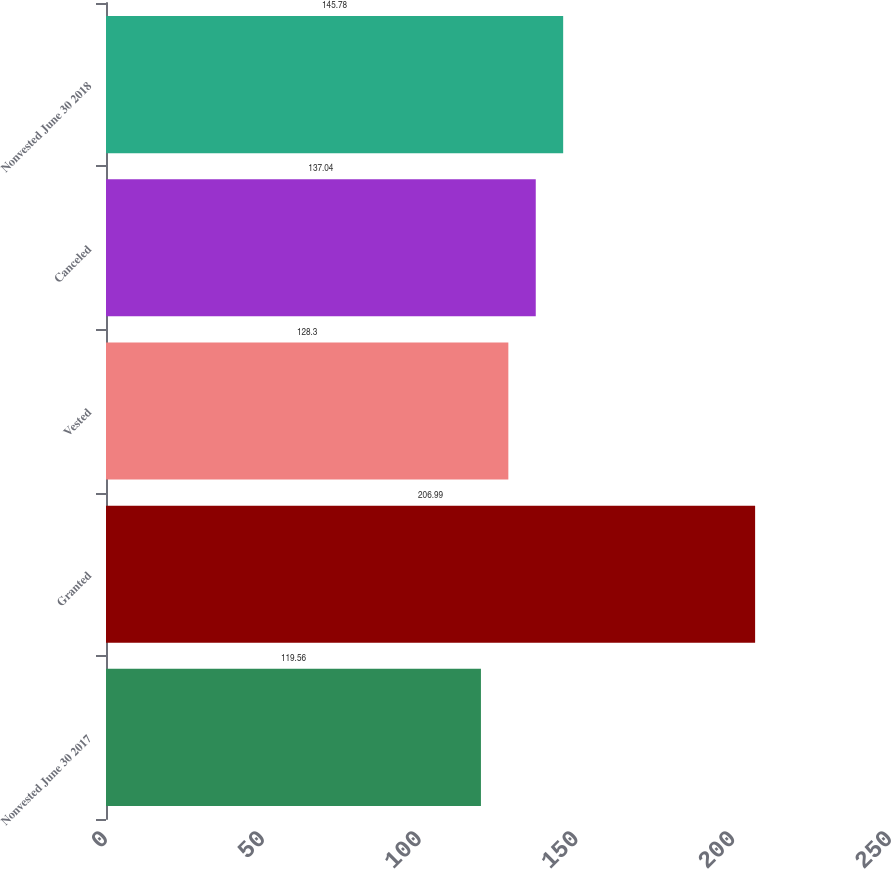<chart> <loc_0><loc_0><loc_500><loc_500><bar_chart><fcel>Nonvested June 30 2017<fcel>Granted<fcel>Vested<fcel>Canceled<fcel>Nonvested June 30 2018<nl><fcel>119.56<fcel>206.99<fcel>128.3<fcel>137.04<fcel>145.78<nl></chart> 